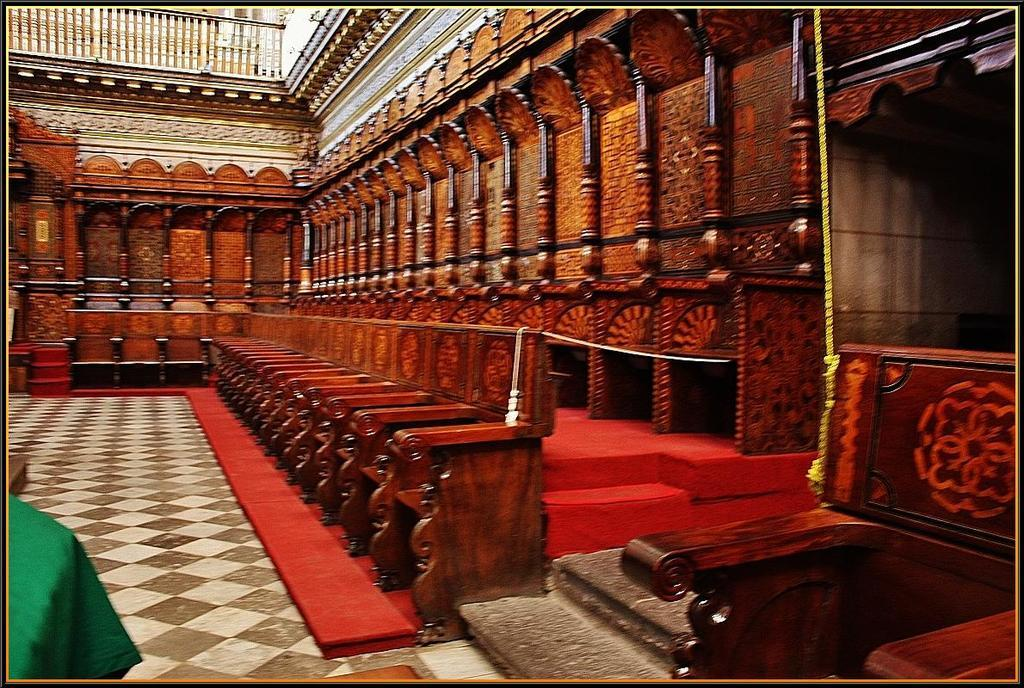What type of location is depicted in the image? The image shows the inside of a building. What type of furniture can be seen in the image? There are chairs in the image. What type of tin can be seen hanging from the ceiling in the image? There is no tin present in the image; it only shows chairs inside a building. 